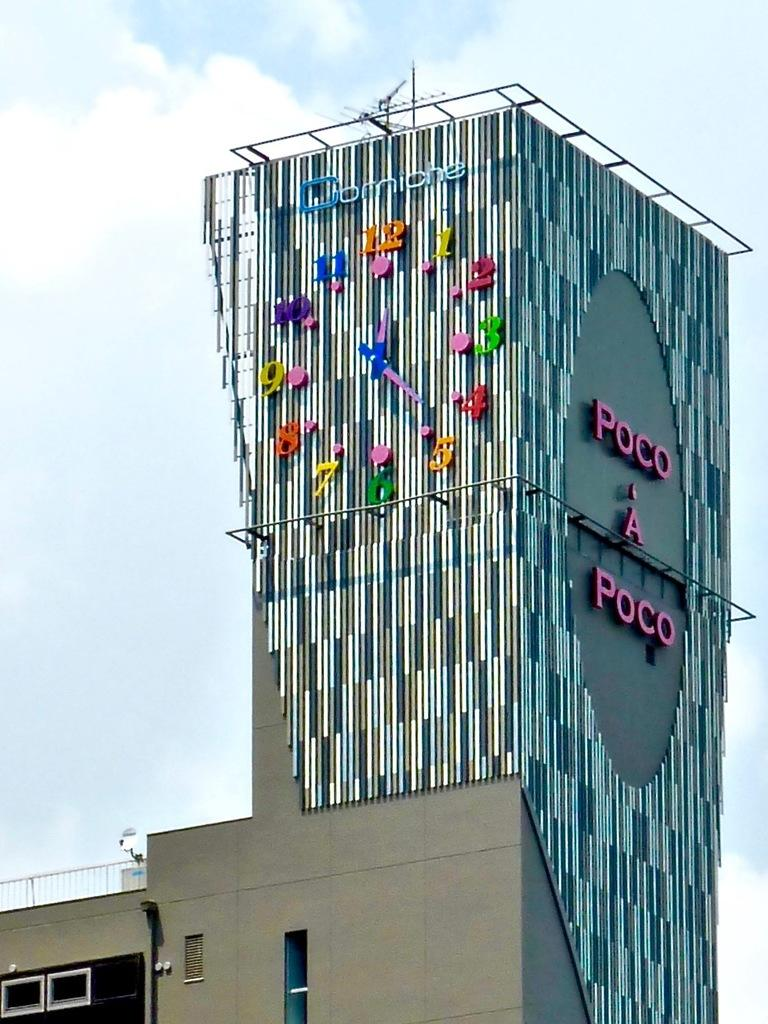What structure is the main subject of the image? There is a building in the image. What feature can be seen on the building? There is a clock on the building. Are there any words or letters on the building? Yes, there is text on the building. What can be seen in the background of the image? The sky is visible in the background of the image. Can you tell me how many frames are present in the image? There are no frames present in the image; it is a photograph or digital image of a building with a clock and text. 